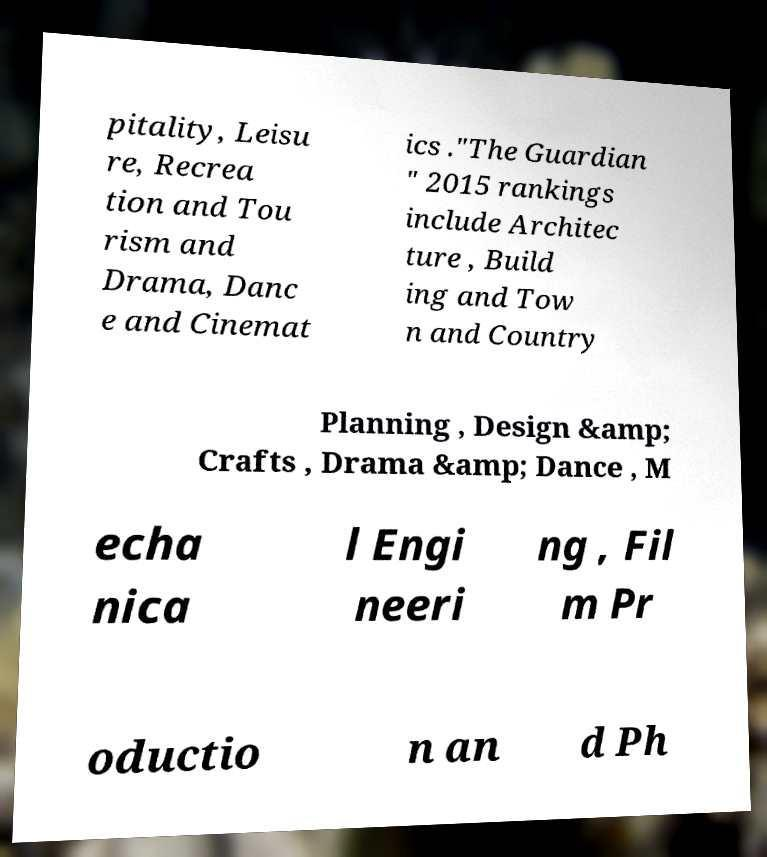For documentation purposes, I need the text within this image transcribed. Could you provide that? pitality, Leisu re, Recrea tion and Tou rism and Drama, Danc e and Cinemat ics ."The Guardian " 2015 rankings include Architec ture , Build ing and Tow n and Country Planning , Design &amp; Crafts , Drama &amp; Dance , M echa nica l Engi neeri ng , Fil m Pr oductio n an d Ph 